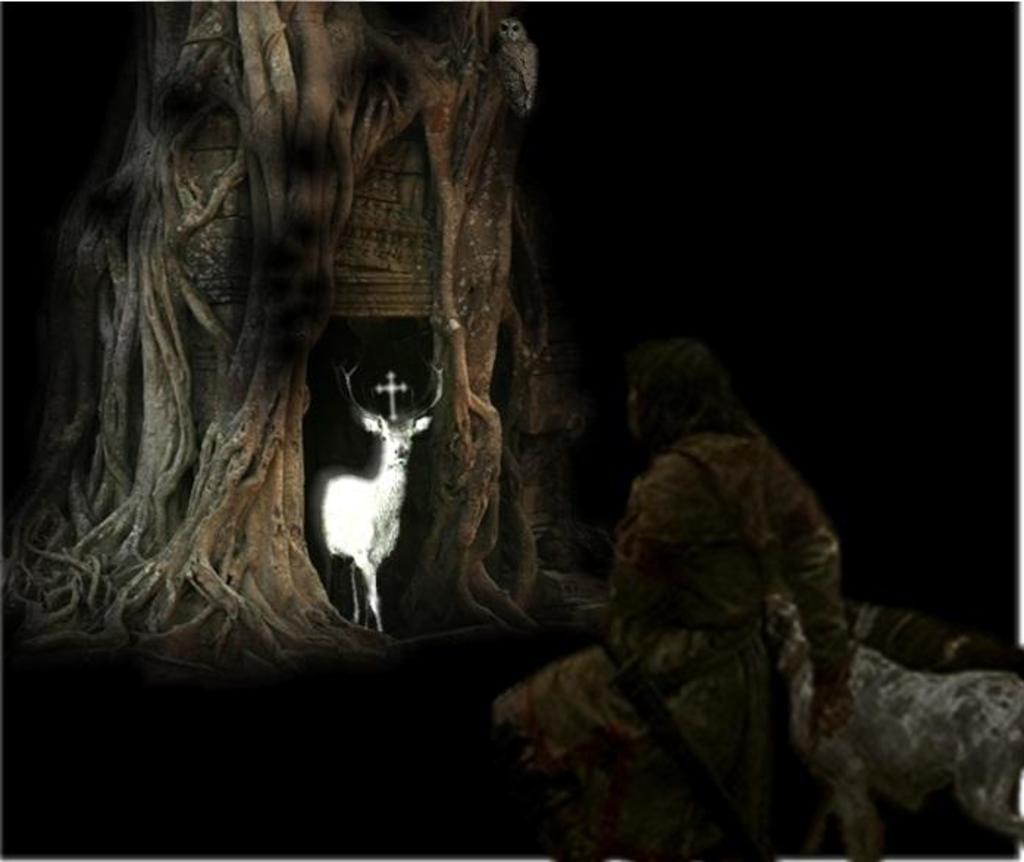In one or two sentences, can you explain what this image depicts? It is an edited image. In this image we can see an animal, a tree and also a person. 